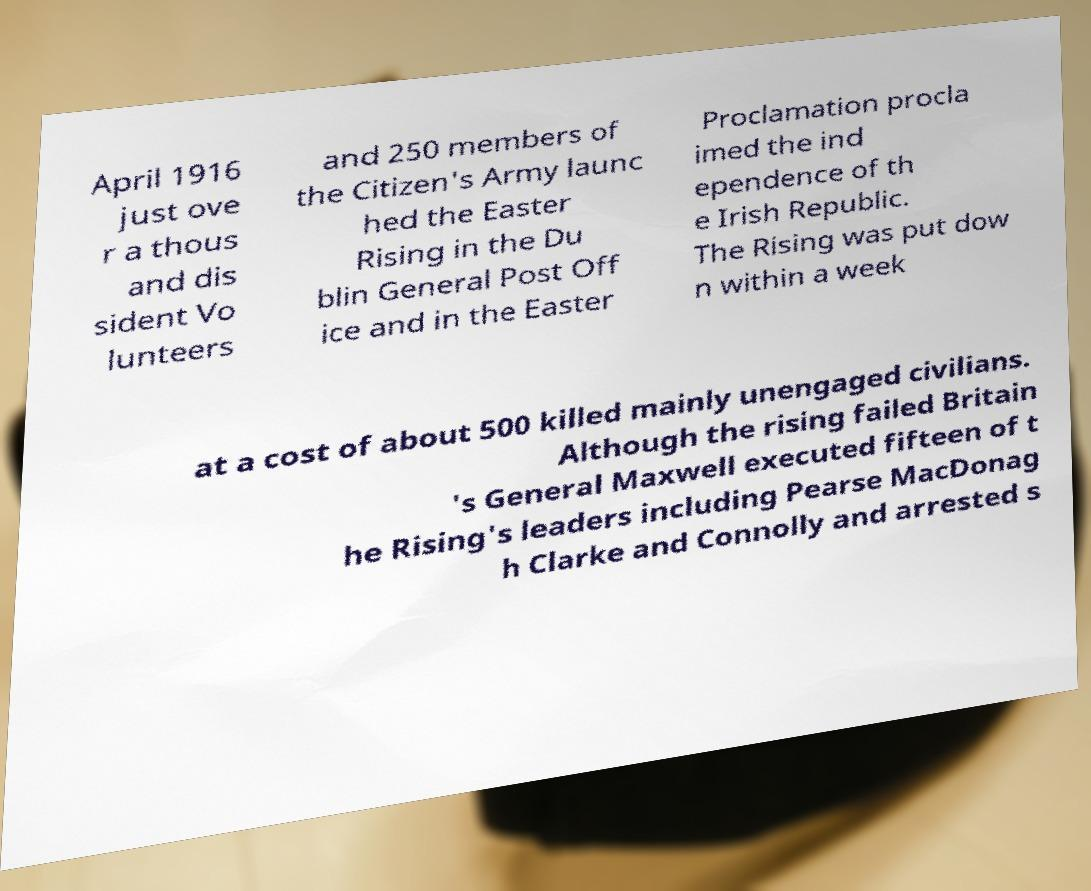There's text embedded in this image that I need extracted. Can you transcribe it verbatim? April 1916 just ove r a thous and dis sident Vo lunteers and 250 members of the Citizen's Army launc hed the Easter Rising in the Du blin General Post Off ice and in the Easter Proclamation procla imed the ind ependence of th e Irish Republic. The Rising was put dow n within a week at a cost of about 500 killed mainly unengaged civilians. Although the rising failed Britain 's General Maxwell executed fifteen of t he Rising's leaders including Pearse MacDonag h Clarke and Connolly and arrested s 